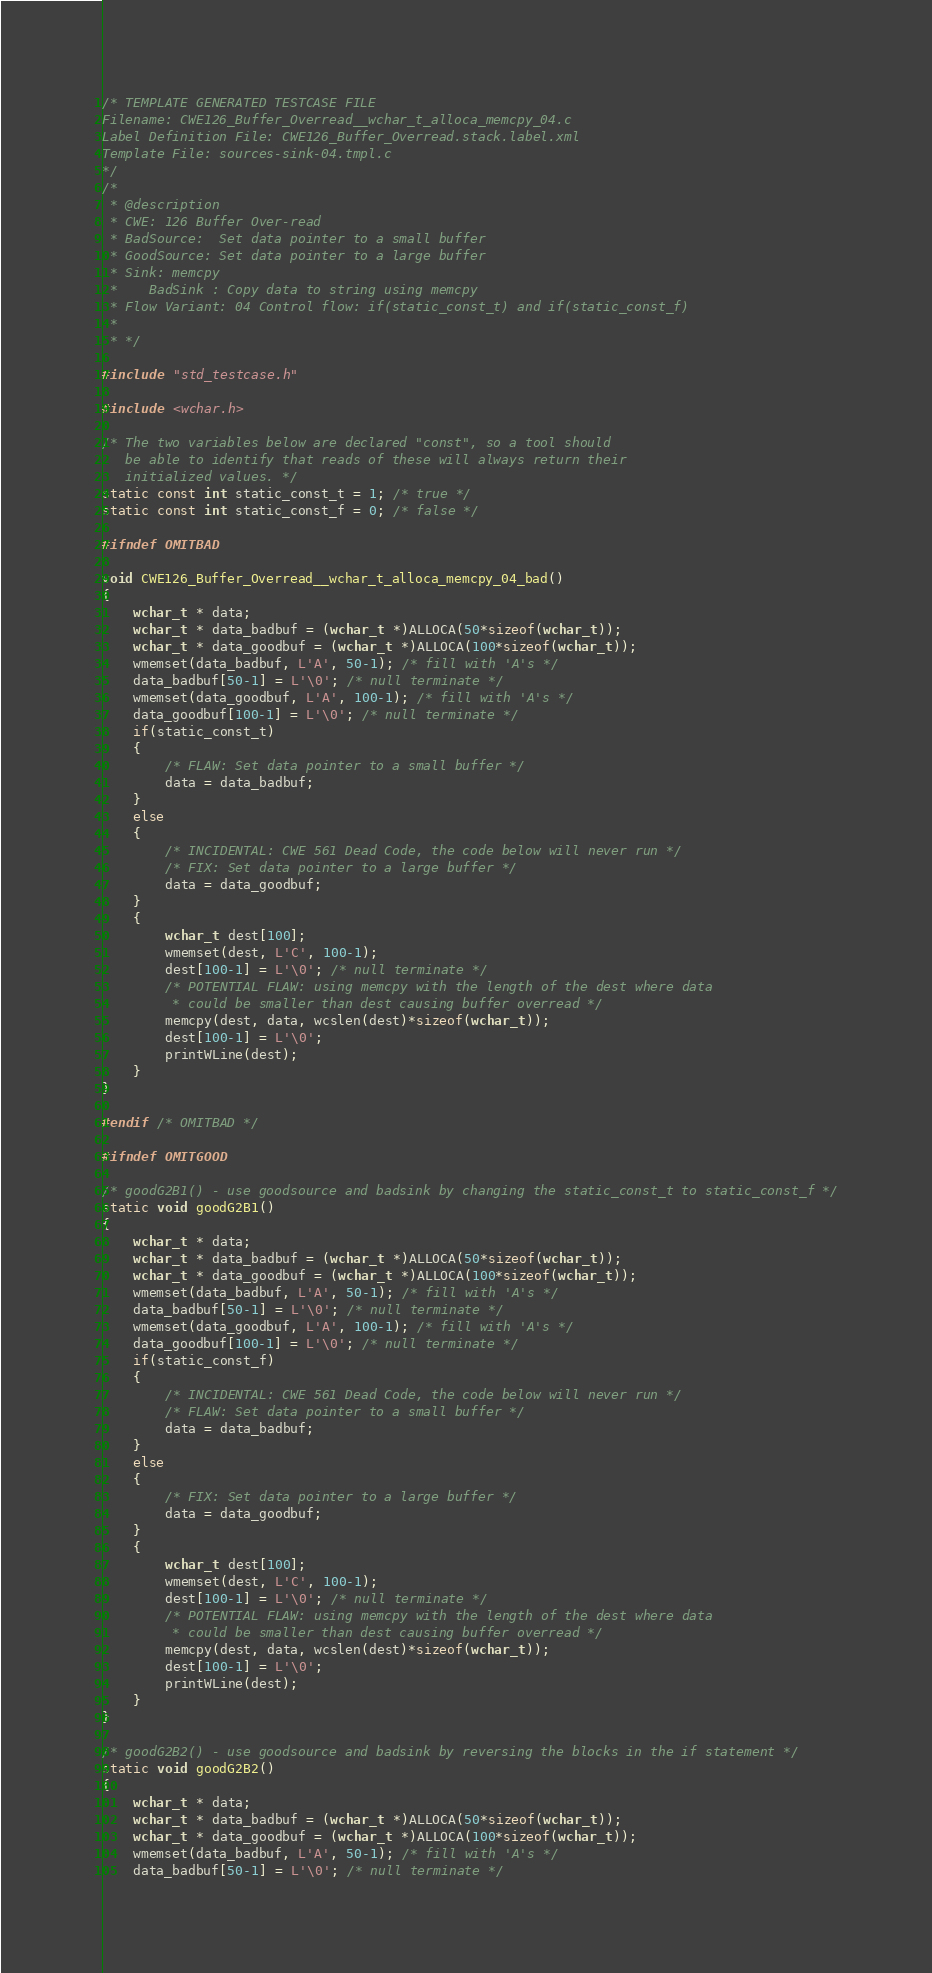Convert code to text. <code><loc_0><loc_0><loc_500><loc_500><_C_>/* TEMPLATE GENERATED TESTCASE FILE
Filename: CWE126_Buffer_Overread__wchar_t_alloca_memcpy_04.c
Label Definition File: CWE126_Buffer_Overread.stack.label.xml
Template File: sources-sink-04.tmpl.c
*/
/*
 * @description
 * CWE: 126 Buffer Over-read
 * BadSource:  Set data pointer to a small buffer
 * GoodSource: Set data pointer to a large buffer
 * Sink: memcpy
 *    BadSink : Copy data to string using memcpy
 * Flow Variant: 04 Control flow: if(static_const_t) and if(static_const_f)
 *
 * */

#include "std_testcase.h"

#include <wchar.h>

/* The two variables below are declared "const", so a tool should
   be able to identify that reads of these will always return their
   initialized values. */
static const int static_const_t = 1; /* true */
static const int static_const_f = 0; /* false */

#ifndef OMITBAD

void CWE126_Buffer_Overread__wchar_t_alloca_memcpy_04_bad()
{
    wchar_t * data;
    wchar_t * data_badbuf = (wchar_t *)ALLOCA(50*sizeof(wchar_t));
    wchar_t * data_goodbuf = (wchar_t *)ALLOCA(100*sizeof(wchar_t));
    wmemset(data_badbuf, L'A', 50-1); /* fill with 'A's */
    data_badbuf[50-1] = L'\0'; /* null terminate */
    wmemset(data_goodbuf, L'A', 100-1); /* fill with 'A's */
    data_goodbuf[100-1] = L'\0'; /* null terminate */
    if(static_const_t)
    {
        /* FLAW: Set data pointer to a small buffer */
        data = data_badbuf;
    }
    else
    {
        /* INCIDENTAL: CWE 561 Dead Code, the code below will never run */
        /* FIX: Set data pointer to a large buffer */
        data = data_goodbuf;
    }
    {
        wchar_t dest[100];
        wmemset(dest, L'C', 100-1);
        dest[100-1] = L'\0'; /* null terminate */
        /* POTENTIAL FLAW: using memcpy with the length of the dest where data
         * could be smaller than dest causing buffer overread */
        memcpy(dest, data, wcslen(dest)*sizeof(wchar_t));
        dest[100-1] = L'\0';
        printWLine(dest);
    }
}

#endif /* OMITBAD */

#ifndef OMITGOOD

/* goodG2B1() - use goodsource and badsink by changing the static_const_t to static_const_f */
static void goodG2B1()
{
    wchar_t * data;
    wchar_t * data_badbuf = (wchar_t *)ALLOCA(50*sizeof(wchar_t));
    wchar_t * data_goodbuf = (wchar_t *)ALLOCA(100*sizeof(wchar_t));
    wmemset(data_badbuf, L'A', 50-1); /* fill with 'A's */
    data_badbuf[50-1] = L'\0'; /* null terminate */
    wmemset(data_goodbuf, L'A', 100-1); /* fill with 'A's */
    data_goodbuf[100-1] = L'\0'; /* null terminate */
    if(static_const_f)
    {
        /* INCIDENTAL: CWE 561 Dead Code, the code below will never run */
        /* FLAW: Set data pointer to a small buffer */
        data = data_badbuf;
    }
    else
    {
        /* FIX: Set data pointer to a large buffer */
        data = data_goodbuf;
    }
    {
        wchar_t dest[100];
        wmemset(dest, L'C', 100-1);
        dest[100-1] = L'\0'; /* null terminate */
        /* POTENTIAL FLAW: using memcpy with the length of the dest where data
         * could be smaller than dest causing buffer overread */
        memcpy(dest, data, wcslen(dest)*sizeof(wchar_t));
        dest[100-1] = L'\0';
        printWLine(dest);
    }
}

/* goodG2B2() - use goodsource and badsink by reversing the blocks in the if statement */
static void goodG2B2()
{
    wchar_t * data;
    wchar_t * data_badbuf = (wchar_t *)ALLOCA(50*sizeof(wchar_t));
    wchar_t * data_goodbuf = (wchar_t *)ALLOCA(100*sizeof(wchar_t));
    wmemset(data_badbuf, L'A', 50-1); /* fill with 'A's */
    data_badbuf[50-1] = L'\0'; /* null terminate */</code> 